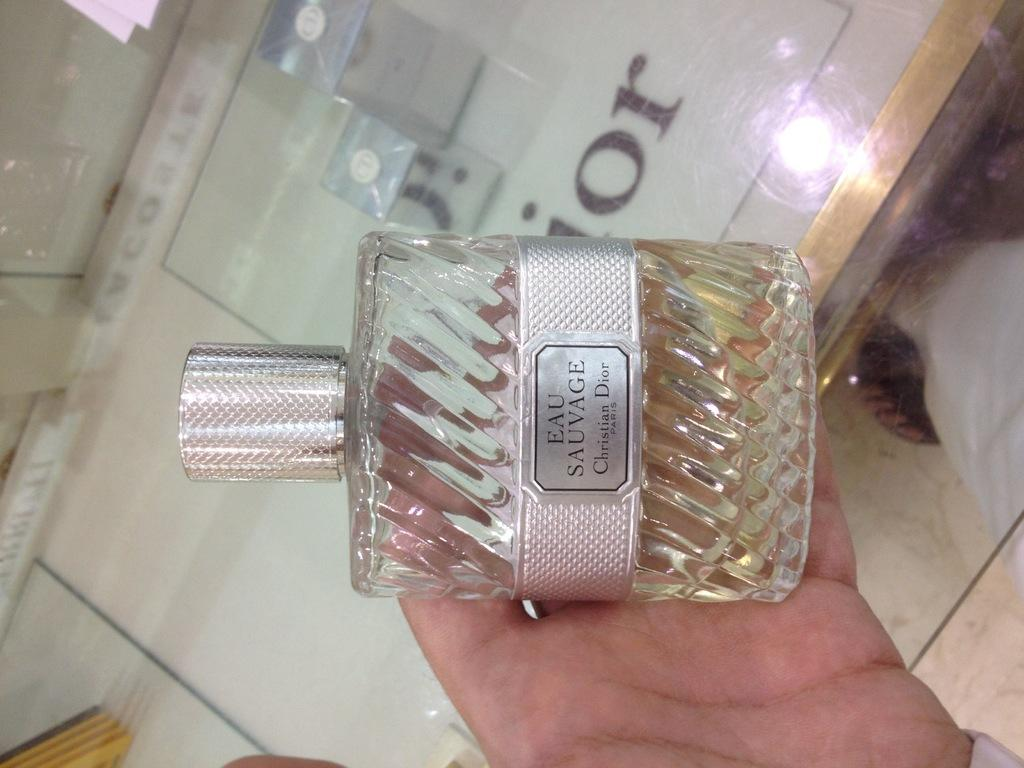Provide a one-sentence caption for the provided image. A bottle of Christian Dior perfume is being held. 